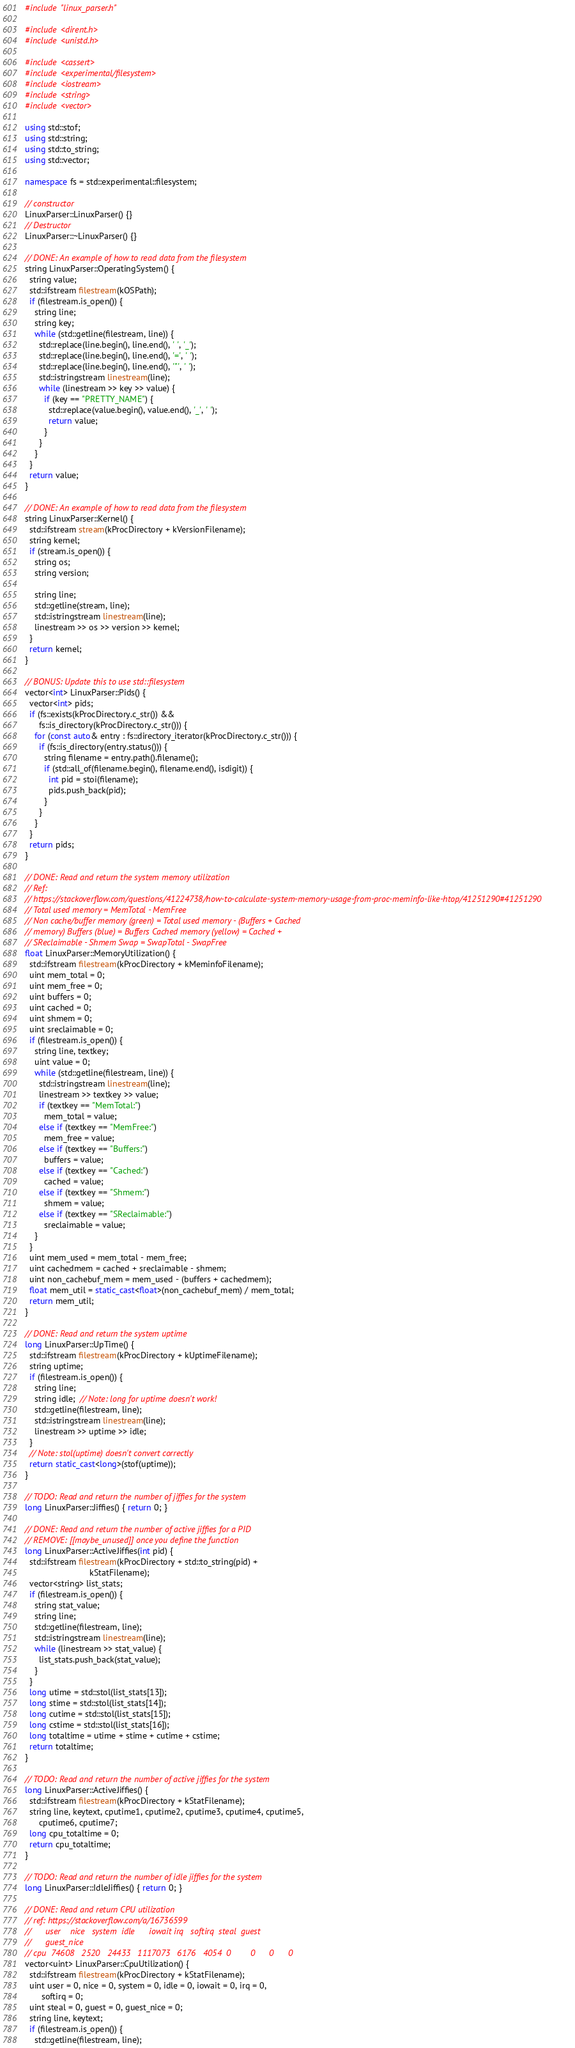<code> <loc_0><loc_0><loc_500><loc_500><_C++_>#include "linux_parser.h"

#include <dirent.h>
#include <unistd.h>

#include <cassert>
#include <experimental/filesystem>
#include <iostream>
#include <string>
#include <vector>

using std::stof;
using std::string;
using std::to_string;
using std::vector;

namespace fs = std::experimental::filesystem;

// constructor
LinuxParser::LinuxParser() {}
// Destructor
LinuxParser::~LinuxParser() {}

// DONE: An example of how to read data from the filesystem
string LinuxParser::OperatingSystem() {
  string value;
  std::ifstream filestream(kOSPath);
  if (filestream.is_open()) {
    string line;
    string key;
    while (std::getline(filestream, line)) {
      std::replace(line.begin(), line.end(), ' ', '_');
      std::replace(line.begin(), line.end(), '=', ' ');
      std::replace(line.begin(), line.end(), '"', ' ');
      std::istringstream linestream(line);
      while (linestream >> key >> value) {
        if (key == "PRETTY_NAME") {
          std::replace(value.begin(), value.end(), '_', ' ');
          return value;
        }
      }
    }
  }
  return value;
}

// DONE: An example of how to read data from the filesystem
string LinuxParser::Kernel() {
  std::ifstream stream(kProcDirectory + kVersionFilename);
  string kernel;
  if (stream.is_open()) {
    string os;
    string version;

    string line;
    std::getline(stream, line);
    std::istringstream linestream(line);
    linestream >> os >> version >> kernel;
  }
  return kernel;
}

// BONUS: Update this to use std::filesystem
vector<int> LinuxParser::Pids() {
  vector<int> pids;
  if (fs::exists(kProcDirectory.c_str()) &&
      fs::is_directory(kProcDirectory.c_str())) {
    for (const auto& entry : fs::directory_iterator(kProcDirectory.c_str())) {
      if (fs::is_directory(entry.status())) {
        string filename = entry.path().filename();
        if (std::all_of(filename.begin(), filename.end(), isdigit)) {
          int pid = stoi(filename);
          pids.push_back(pid);
        }
      }
    }
  }
  return pids;
}

// DONE: Read and return the system memory utilization
// Ref:
// https://stackoverflow.com/questions/41224738/how-to-calculate-system-memory-usage-from-proc-meminfo-like-htop/41251290#41251290
// Total used memory = MemTotal - MemFree
// Non cache/buffer memory (green) = Total used memory - (Buffers + Cached
// memory) Buffers (blue) = Buffers Cached memory (yellow) = Cached +
// SReclaimable - Shmem Swap = SwapTotal - SwapFree
float LinuxParser::MemoryUtilization() {
  std::ifstream filestream(kProcDirectory + kMeminfoFilename);
  uint mem_total = 0;
  uint mem_free = 0;
  uint buffers = 0;
  uint cached = 0;
  uint shmem = 0;
  uint sreclaimable = 0;
  if (filestream.is_open()) {
    string line, textkey;
    uint value = 0;
    while (std::getline(filestream, line)) {
      std::istringstream linestream(line);
      linestream >> textkey >> value;
      if (textkey == "MemTotal:")
        mem_total = value;
      else if (textkey == "MemFree:")
        mem_free = value;
      else if (textkey == "Buffers:")
        buffers = value;
      else if (textkey == "Cached:")
        cached = value;
      else if (textkey == "Shmem:")
        shmem = value;
      else if (textkey == "SReclaimable:")
        sreclaimable = value;
    }
  }
  uint mem_used = mem_total - mem_free;
  uint cachedmem = cached + sreclaimable - shmem;
  uint non_cachebuf_mem = mem_used - (buffers + cachedmem);
  float mem_util = static_cast<float>(non_cachebuf_mem) / mem_total;
  return mem_util;
}

// DONE: Read and return the system uptime
long LinuxParser::UpTime() {
  std::ifstream filestream(kProcDirectory + kUptimeFilename);
  string uptime;
  if (filestream.is_open()) {
    string line;
    string idle;  // Note: long for uptime doesn't work!
    std::getline(filestream, line);
    std::istringstream linestream(line);
    linestream >> uptime >> idle;
  }
  // Note: stol(uptime) doesn't convert correctly
  return static_cast<long>(stof(uptime));
}

// TODO: Read and return the number of jiffies for the system
long LinuxParser::Jiffies() { return 0; }

// DONE: Read and return the number of active jiffies for a PID
// REMOVE: [[maybe_unused]] once you define the function
long LinuxParser::ActiveJiffies(int pid) {
  std::ifstream filestream(kProcDirectory + std::to_string(pid) +
                           kStatFilename);
  vector<string> list_stats;
  if (filestream.is_open()) {
    string stat_value;
    string line;
    std::getline(filestream, line);
    std::istringstream linestream(line);
    while (linestream >> stat_value) {
      list_stats.push_back(stat_value);
    }
  }
  long utime = std::stol(list_stats[13]);
  long stime = std::stol(list_stats[14]);
  long cutime = std::stol(list_stats[15]);
  long cstime = std::stol(list_stats[16]);
  long totaltime = utime + stime + cutime + cstime;
  return totaltime;
}

// TODO: Read and return the number of active jiffies for the system
long LinuxParser::ActiveJiffies() {
  std::ifstream filestream(kProcDirectory + kStatFilename);
  string line, keytext, cputime1, cputime2, cputime3, cputime4, cputime5,
      cputime6, cputime7;
  long cpu_totaltime = 0;
  return cpu_totaltime;
}

// TODO: Read and return the number of idle jiffies for the system
long LinuxParser::IdleJiffies() { return 0; }

// DONE: Read and return CPU utilization
// ref: https://stackoverflow.com/a/16736599
//      user    nice   system  idle      iowait irq   softirq  steal  guest
//      guest_nice
// cpu  74608   2520   24433   1117073   6176   4054  0        0      0      0
vector<uint> LinuxParser::CpuUtilization() {
  std::ifstream filestream(kProcDirectory + kStatFilename);
  uint user = 0, nice = 0, system = 0, idle = 0, iowait = 0, irq = 0,
       softirq = 0;
  uint steal = 0, guest = 0, guest_nice = 0;
  string line, keytext;
  if (filestream.is_open()) {
    std::getline(filestream, line);</code> 